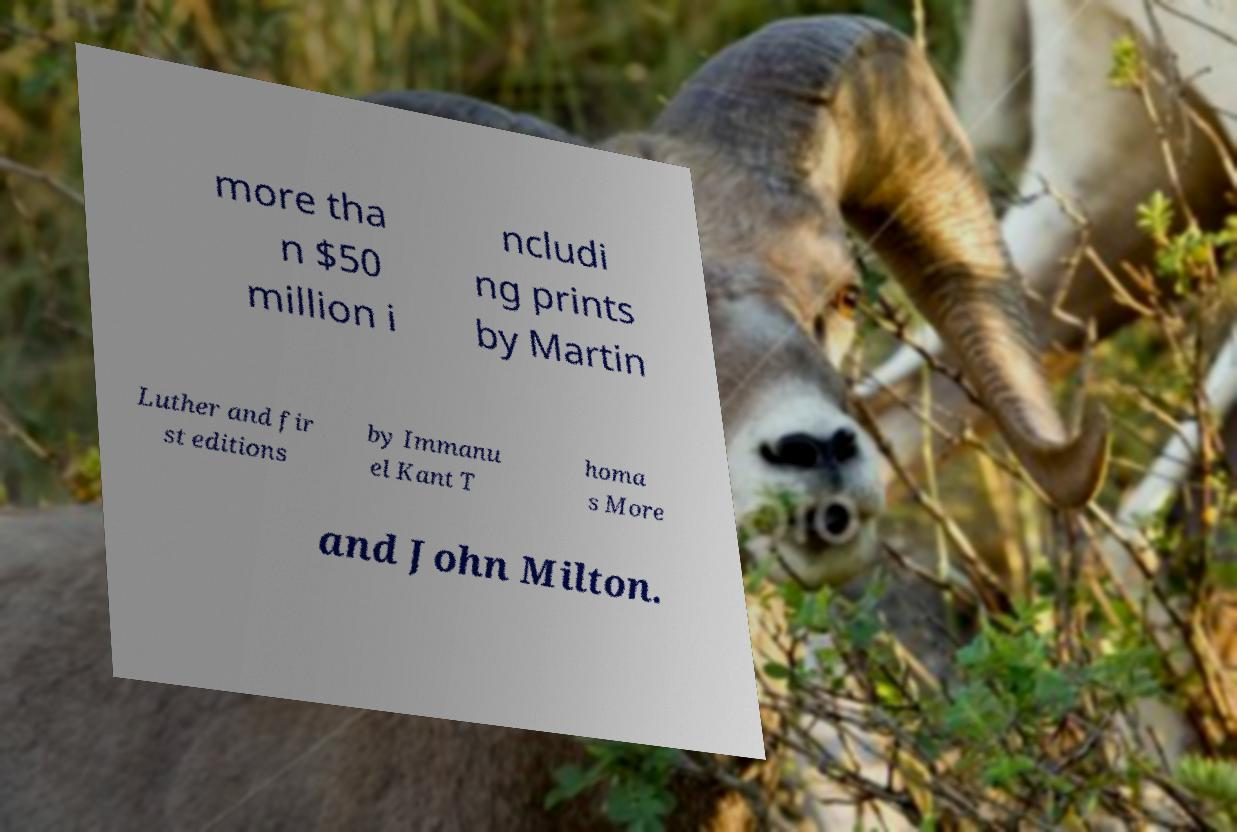What messages or text are displayed in this image? I need them in a readable, typed format. more tha n $50 million i ncludi ng prints by Martin Luther and fir st editions by Immanu el Kant T homa s More and John Milton. 